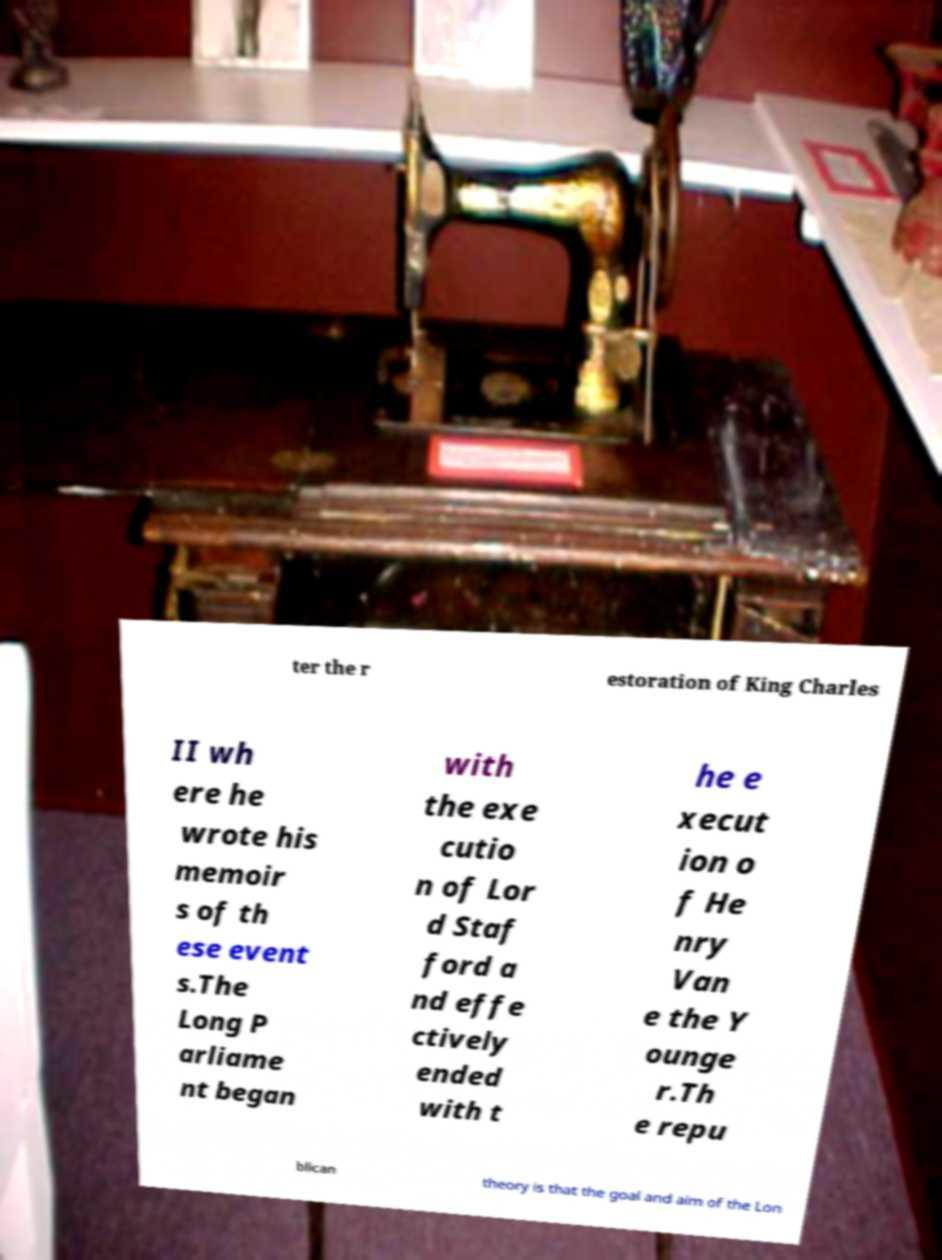What messages or text are displayed in this image? I need them in a readable, typed format. ter the r estoration of King Charles II wh ere he wrote his memoir s of th ese event s.The Long P arliame nt began with the exe cutio n of Lor d Staf ford a nd effe ctively ended with t he e xecut ion o f He nry Van e the Y ounge r.Th e repu blican theory is that the goal and aim of the Lon 